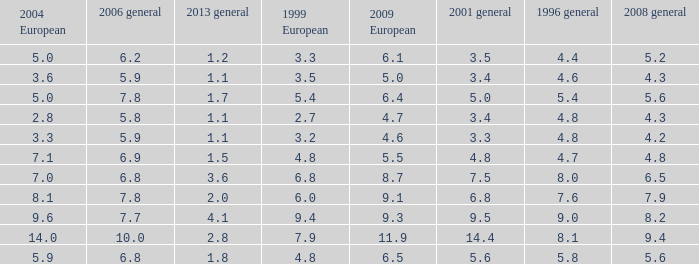What is the average value for general 2001 with more than 4.8 in 1999 European, 7.7 in 2006 general, and more than 9 in 1996 general? None. 